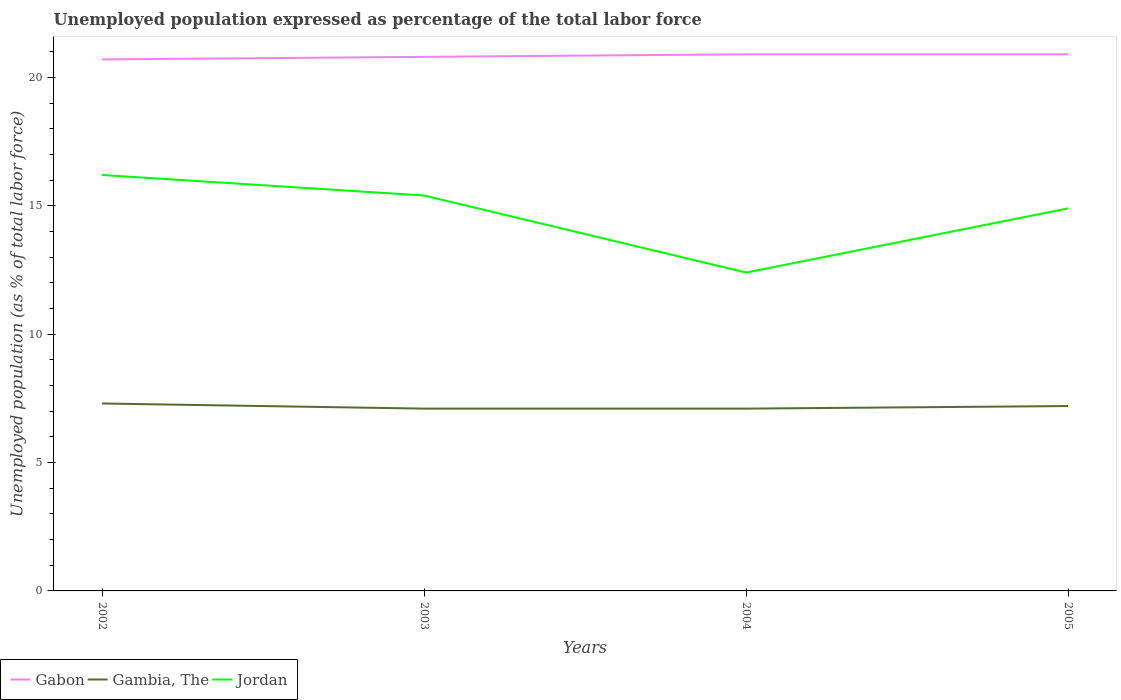Across all years, what is the maximum unemployment in in Gambia, The?
Make the answer very short. 7.1. In which year was the unemployment in in Jordan maximum?
Provide a short and direct response. 2004. What is the total unemployment in in Gabon in the graph?
Provide a succinct answer. -0.1. What is the difference between the highest and the second highest unemployment in in Gabon?
Offer a terse response. 0.2. Is the unemployment in in Gambia, The strictly greater than the unemployment in in Gabon over the years?
Give a very brief answer. Yes. How many years are there in the graph?
Provide a short and direct response. 4. What is the difference between two consecutive major ticks on the Y-axis?
Your answer should be compact. 5. How are the legend labels stacked?
Your response must be concise. Horizontal. What is the title of the graph?
Offer a terse response. Unemployed population expressed as percentage of the total labor force. Does "Low income" appear as one of the legend labels in the graph?
Give a very brief answer. No. What is the label or title of the Y-axis?
Provide a succinct answer. Unemployed population (as % of total labor force). What is the Unemployed population (as % of total labor force) in Gabon in 2002?
Ensure brevity in your answer.  20.7. What is the Unemployed population (as % of total labor force) of Gambia, The in 2002?
Offer a terse response. 7.3. What is the Unemployed population (as % of total labor force) in Jordan in 2002?
Ensure brevity in your answer.  16.2. What is the Unemployed population (as % of total labor force) in Gabon in 2003?
Your answer should be compact. 20.8. What is the Unemployed population (as % of total labor force) of Gambia, The in 2003?
Your answer should be very brief. 7.1. What is the Unemployed population (as % of total labor force) of Jordan in 2003?
Provide a succinct answer. 15.4. What is the Unemployed population (as % of total labor force) of Gabon in 2004?
Keep it short and to the point. 20.9. What is the Unemployed population (as % of total labor force) in Gambia, The in 2004?
Offer a very short reply. 7.1. What is the Unemployed population (as % of total labor force) in Jordan in 2004?
Your response must be concise. 12.4. What is the Unemployed population (as % of total labor force) in Gabon in 2005?
Your response must be concise. 20.9. What is the Unemployed population (as % of total labor force) of Gambia, The in 2005?
Keep it short and to the point. 7.2. What is the Unemployed population (as % of total labor force) of Jordan in 2005?
Provide a short and direct response. 14.9. Across all years, what is the maximum Unemployed population (as % of total labor force) of Gabon?
Offer a very short reply. 20.9. Across all years, what is the maximum Unemployed population (as % of total labor force) in Gambia, The?
Ensure brevity in your answer.  7.3. Across all years, what is the maximum Unemployed population (as % of total labor force) in Jordan?
Your response must be concise. 16.2. Across all years, what is the minimum Unemployed population (as % of total labor force) in Gabon?
Keep it short and to the point. 20.7. Across all years, what is the minimum Unemployed population (as % of total labor force) in Gambia, The?
Your response must be concise. 7.1. Across all years, what is the minimum Unemployed population (as % of total labor force) in Jordan?
Your answer should be compact. 12.4. What is the total Unemployed population (as % of total labor force) in Gabon in the graph?
Ensure brevity in your answer.  83.3. What is the total Unemployed population (as % of total labor force) in Gambia, The in the graph?
Provide a succinct answer. 28.7. What is the total Unemployed population (as % of total labor force) of Jordan in the graph?
Give a very brief answer. 58.9. What is the difference between the Unemployed population (as % of total labor force) in Gabon in 2002 and that in 2003?
Offer a very short reply. -0.1. What is the difference between the Unemployed population (as % of total labor force) of Gambia, The in 2002 and that in 2004?
Ensure brevity in your answer.  0.2. What is the difference between the Unemployed population (as % of total labor force) of Jordan in 2002 and that in 2004?
Offer a terse response. 3.8. What is the difference between the Unemployed population (as % of total labor force) in Gabon in 2002 and that in 2005?
Ensure brevity in your answer.  -0.2. What is the difference between the Unemployed population (as % of total labor force) of Gabon in 2004 and that in 2005?
Your answer should be very brief. 0. What is the difference between the Unemployed population (as % of total labor force) in Gabon in 2002 and the Unemployed population (as % of total labor force) in Gambia, The in 2005?
Give a very brief answer. 13.5. What is the difference between the Unemployed population (as % of total labor force) of Gambia, The in 2003 and the Unemployed population (as % of total labor force) of Jordan in 2004?
Offer a terse response. -5.3. What is the average Unemployed population (as % of total labor force) of Gabon per year?
Your response must be concise. 20.82. What is the average Unemployed population (as % of total labor force) of Gambia, The per year?
Ensure brevity in your answer.  7.17. What is the average Unemployed population (as % of total labor force) in Jordan per year?
Your response must be concise. 14.72. In the year 2002, what is the difference between the Unemployed population (as % of total labor force) of Gabon and Unemployed population (as % of total labor force) of Gambia, The?
Your response must be concise. 13.4. In the year 2002, what is the difference between the Unemployed population (as % of total labor force) in Gambia, The and Unemployed population (as % of total labor force) in Jordan?
Provide a short and direct response. -8.9. In the year 2003, what is the difference between the Unemployed population (as % of total labor force) in Gambia, The and Unemployed population (as % of total labor force) in Jordan?
Your answer should be very brief. -8.3. In the year 2004, what is the difference between the Unemployed population (as % of total labor force) of Gabon and Unemployed population (as % of total labor force) of Gambia, The?
Offer a very short reply. 13.8. In the year 2005, what is the difference between the Unemployed population (as % of total labor force) in Gabon and Unemployed population (as % of total labor force) in Gambia, The?
Your answer should be very brief. 13.7. In the year 2005, what is the difference between the Unemployed population (as % of total labor force) of Gabon and Unemployed population (as % of total labor force) of Jordan?
Give a very brief answer. 6. In the year 2005, what is the difference between the Unemployed population (as % of total labor force) in Gambia, The and Unemployed population (as % of total labor force) in Jordan?
Offer a terse response. -7.7. What is the ratio of the Unemployed population (as % of total labor force) in Gambia, The in 2002 to that in 2003?
Offer a terse response. 1.03. What is the ratio of the Unemployed population (as % of total labor force) of Jordan in 2002 to that in 2003?
Provide a short and direct response. 1.05. What is the ratio of the Unemployed population (as % of total labor force) of Gabon in 2002 to that in 2004?
Offer a very short reply. 0.99. What is the ratio of the Unemployed population (as % of total labor force) of Gambia, The in 2002 to that in 2004?
Ensure brevity in your answer.  1.03. What is the ratio of the Unemployed population (as % of total labor force) of Jordan in 2002 to that in 2004?
Keep it short and to the point. 1.31. What is the ratio of the Unemployed population (as % of total labor force) in Gabon in 2002 to that in 2005?
Provide a short and direct response. 0.99. What is the ratio of the Unemployed population (as % of total labor force) in Gambia, The in 2002 to that in 2005?
Keep it short and to the point. 1.01. What is the ratio of the Unemployed population (as % of total labor force) in Jordan in 2002 to that in 2005?
Keep it short and to the point. 1.09. What is the ratio of the Unemployed population (as % of total labor force) of Jordan in 2003 to that in 2004?
Your answer should be very brief. 1.24. What is the ratio of the Unemployed population (as % of total labor force) of Gambia, The in 2003 to that in 2005?
Give a very brief answer. 0.99. What is the ratio of the Unemployed population (as % of total labor force) in Jordan in 2003 to that in 2005?
Keep it short and to the point. 1.03. What is the ratio of the Unemployed population (as % of total labor force) of Gambia, The in 2004 to that in 2005?
Make the answer very short. 0.99. What is the ratio of the Unemployed population (as % of total labor force) in Jordan in 2004 to that in 2005?
Keep it short and to the point. 0.83. What is the difference between the highest and the second highest Unemployed population (as % of total labor force) of Gambia, The?
Provide a short and direct response. 0.1. 